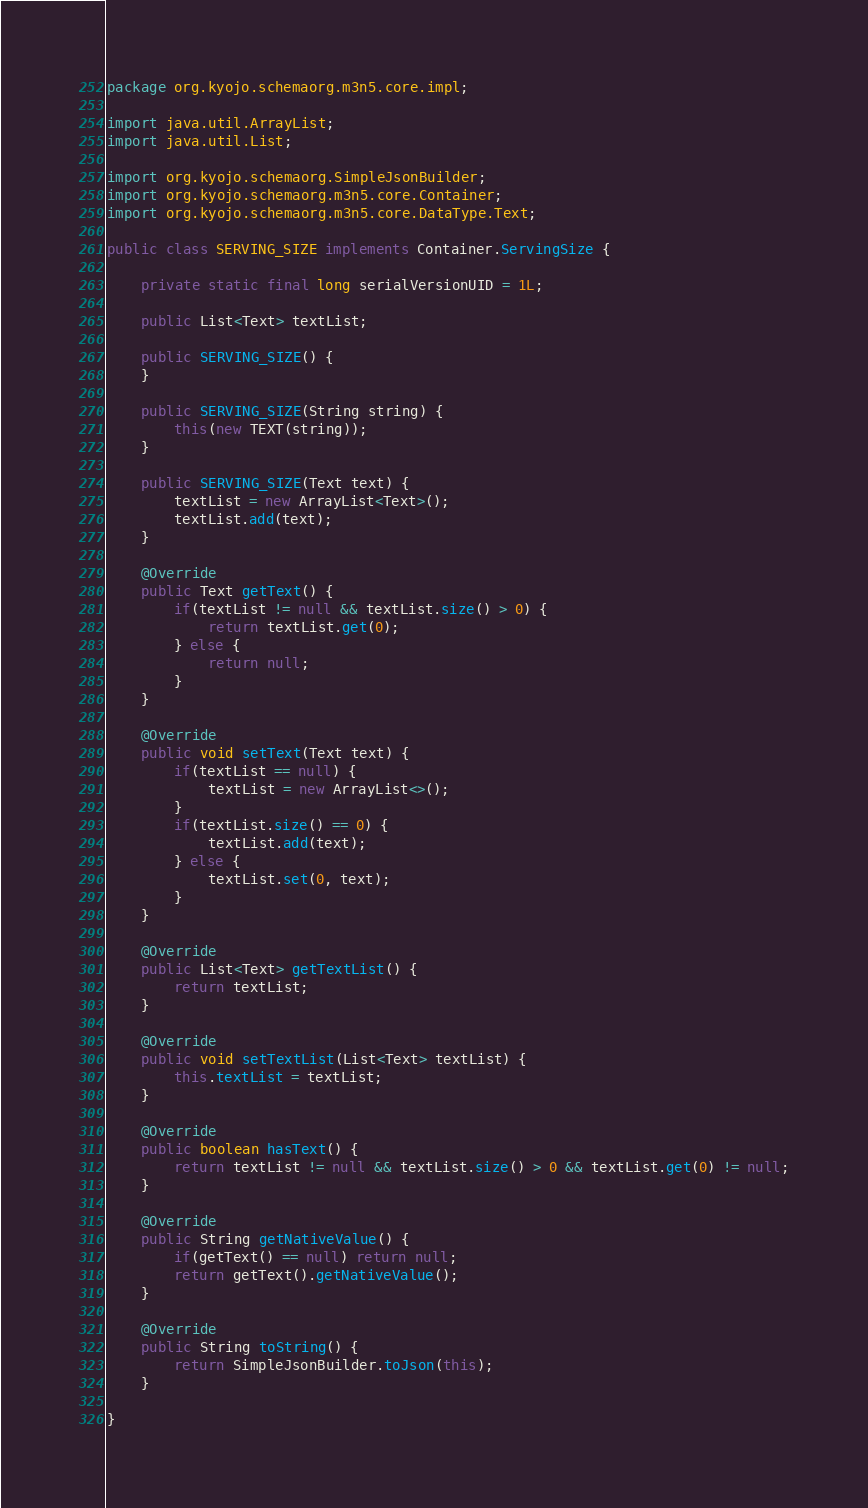<code> <loc_0><loc_0><loc_500><loc_500><_Java_>package org.kyojo.schemaorg.m3n5.core.impl;

import java.util.ArrayList;
import java.util.List;

import org.kyojo.schemaorg.SimpleJsonBuilder;
import org.kyojo.schemaorg.m3n5.core.Container;
import org.kyojo.schemaorg.m3n5.core.DataType.Text;

public class SERVING_SIZE implements Container.ServingSize {

	private static final long serialVersionUID = 1L;

	public List<Text> textList;

	public SERVING_SIZE() {
	}

	public SERVING_SIZE(String string) {
		this(new TEXT(string));
	}

	public SERVING_SIZE(Text text) {
		textList = new ArrayList<Text>();
		textList.add(text);
	}

	@Override
	public Text getText() {
		if(textList != null && textList.size() > 0) {
			return textList.get(0);
		} else {
			return null;
		}
	}

	@Override
	public void setText(Text text) {
		if(textList == null) {
			textList = new ArrayList<>();
		}
		if(textList.size() == 0) {
			textList.add(text);
		} else {
			textList.set(0, text);
		}
	}

	@Override
	public List<Text> getTextList() {
		return textList;
	}

	@Override
	public void setTextList(List<Text> textList) {
		this.textList = textList;
	}

	@Override
	public boolean hasText() {
		return textList != null && textList.size() > 0 && textList.get(0) != null;
	}

	@Override
	public String getNativeValue() {
		if(getText() == null) return null;
		return getText().getNativeValue();
	}

	@Override
	public String toString() {
		return SimpleJsonBuilder.toJson(this);
	}

}
</code> 